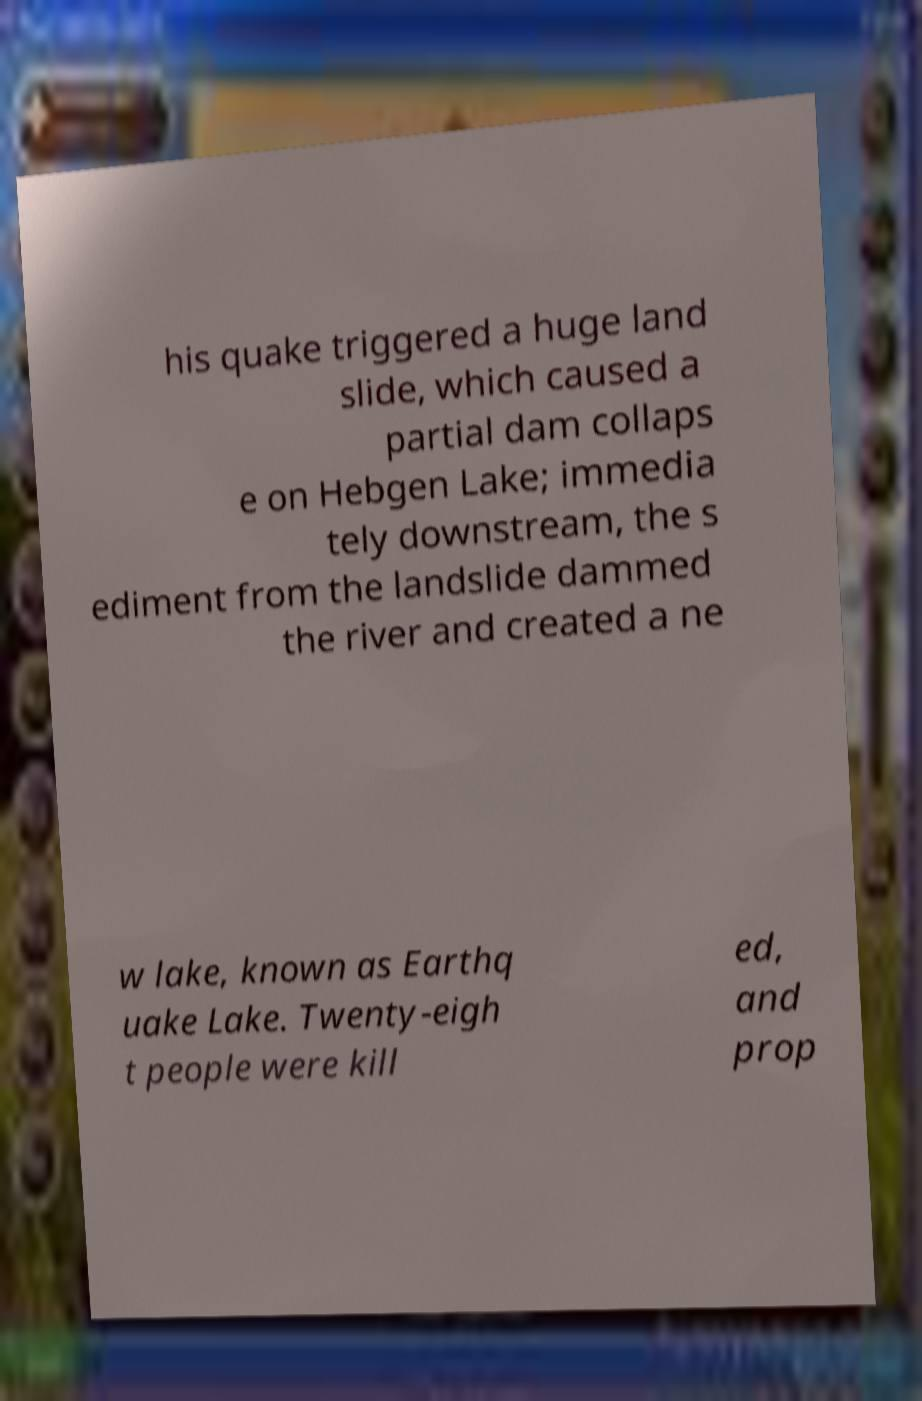Please read and relay the text visible in this image. What does it say? his quake triggered a huge land slide, which caused a partial dam collaps e on Hebgen Lake; immedia tely downstream, the s ediment from the landslide dammed the river and created a ne w lake, known as Earthq uake Lake. Twenty-eigh t people were kill ed, and prop 